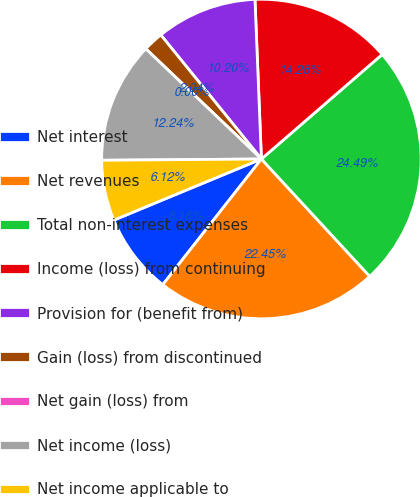<chart> <loc_0><loc_0><loc_500><loc_500><pie_chart><fcel>Net interest<fcel>Net revenues<fcel>Total non-interest expenses<fcel>Income (loss) from continuing<fcel>Provision for (benefit from)<fcel>Gain (loss) from discontinued<fcel>Net gain (loss) from<fcel>Net income (loss)<fcel>Net income applicable to<nl><fcel>8.16%<fcel>22.45%<fcel>24.49%<fcel>14.28%<fcel>10.2%<fcel>2.04%<fcel>0.0%<fcel>12.24%<fcel>6.12%<nl></chart> 